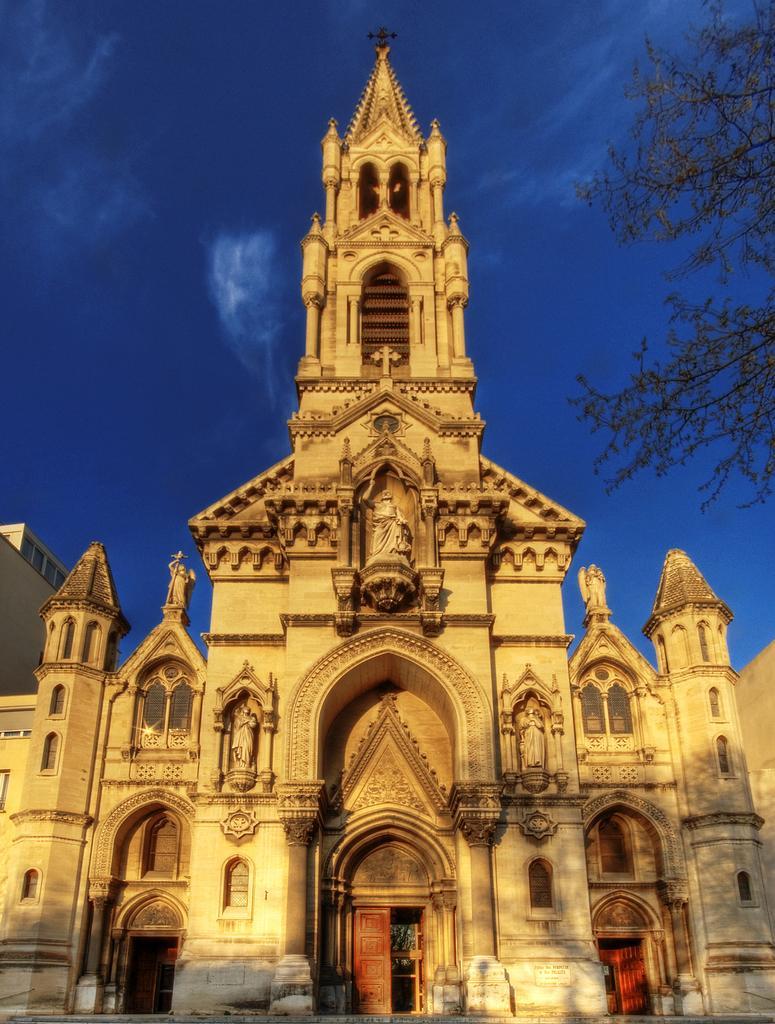In one or two sentences, can you explain what this image depicts? In this image there is a cathedral. There are sculptures on the walls of the cathedral. At the bottom there are doors. On the top there is a cross. To the right there are leaves of a tree. At the top there is the sky. 